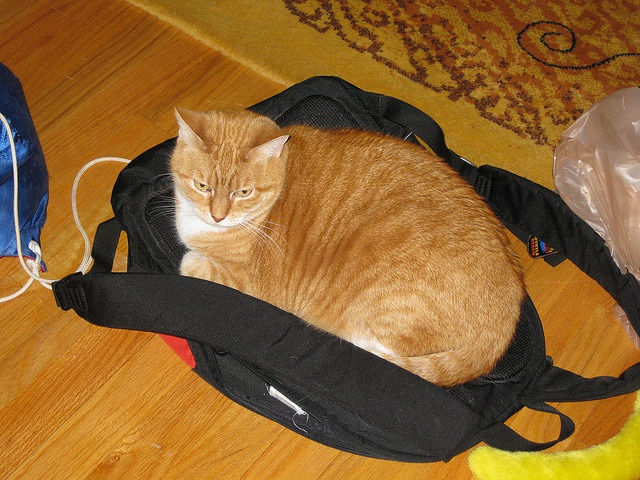Describe the objects in this image and their specific colors. I can see cat in maroon, olive, and tan tones and backpack in maroon, black, and gray tones in this image. 